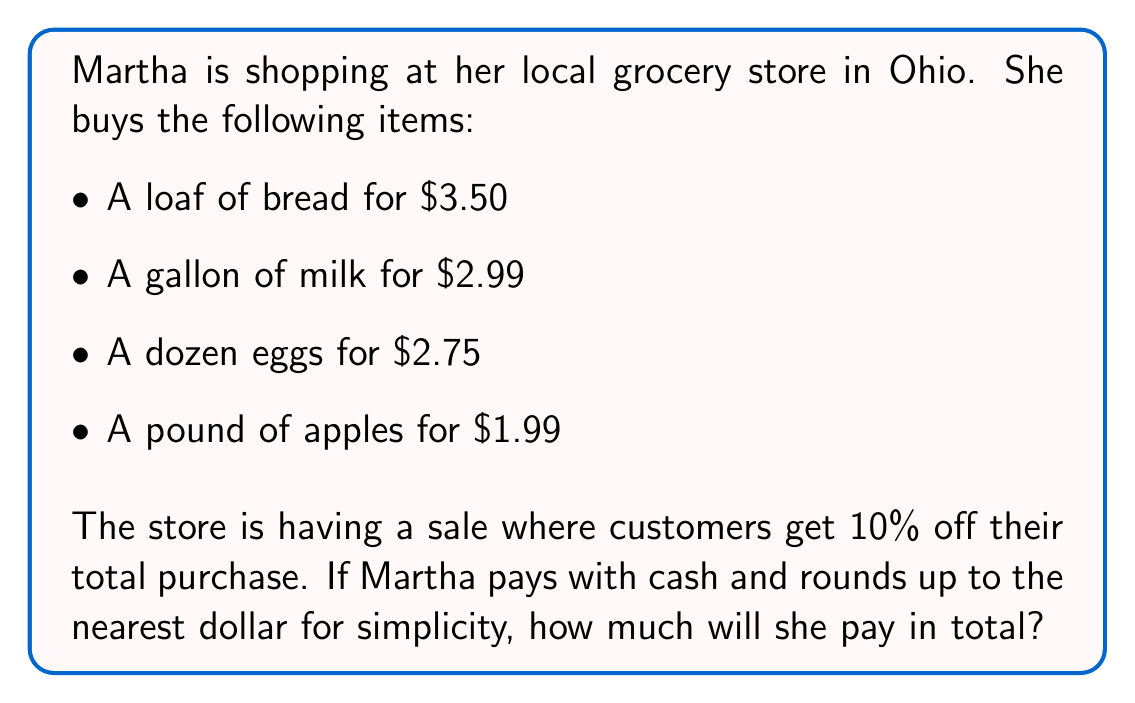Could you help me with this problem? Let's solve this problem step by step:

1. First, we need to calculate the total cost before the discount:
   $$ 3.50 + 2.99 + 2.75 + 1.99 = $11.23 $$

2. Now, we need to calculate the 10% discount:
   $$ 10\% \text{ of } $11.23 = 0.10 \times $11.23 = $1.123 $$

3. Subtract the discount from the original total:
   $$ $11.23 - $1.123 = $10.107 $$

4. Since Martha is rounding up to the nearest dollar for simplicity, we need to round $10.107 up to $11.

Therefore, Martha will pay $11 in cash for her groceries after the discount and rounding up.
Answer: $11 